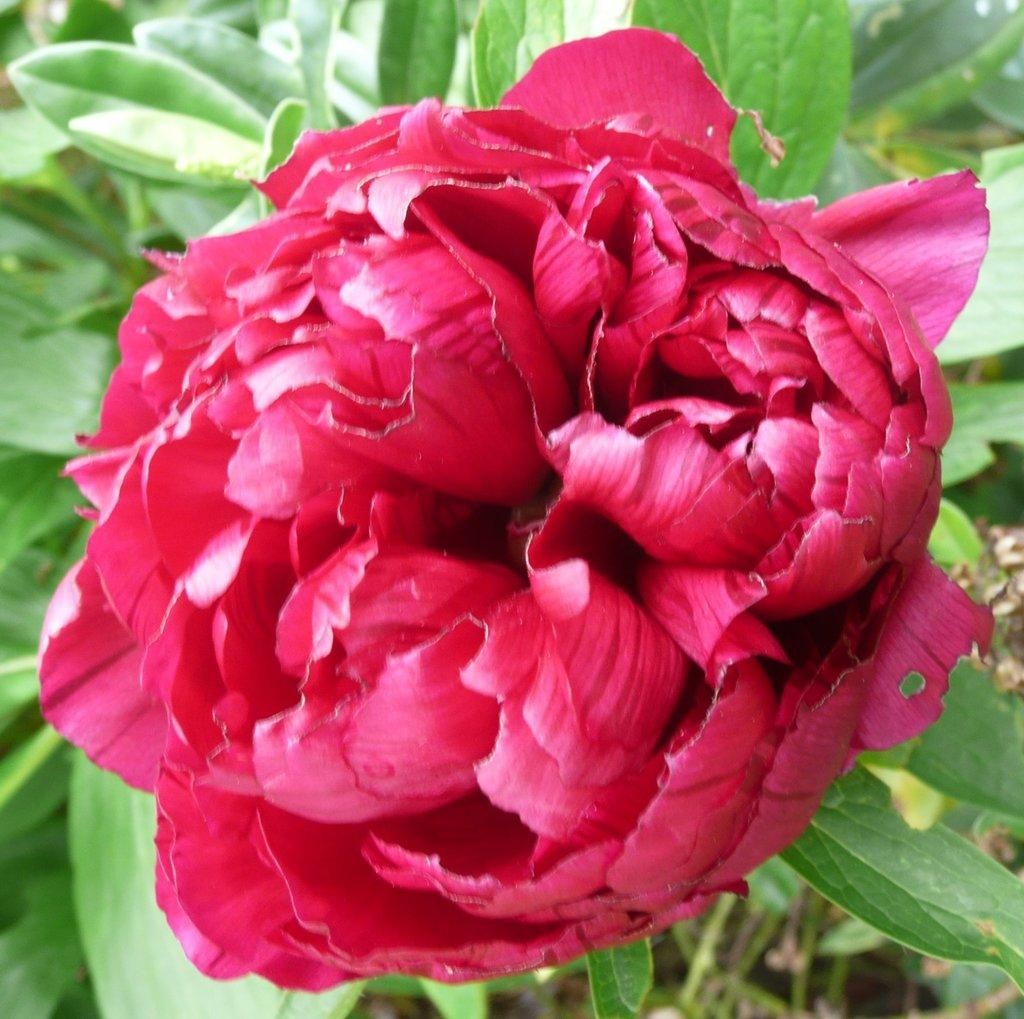What type of plant is visible in the image? There is a flower in the image. Can you describe the background of the image? There is a plant in the background of the image. What type of soda is being advertised in the image? There is no soda or advertisement present in the image; it features a flower and a plant in the background. 